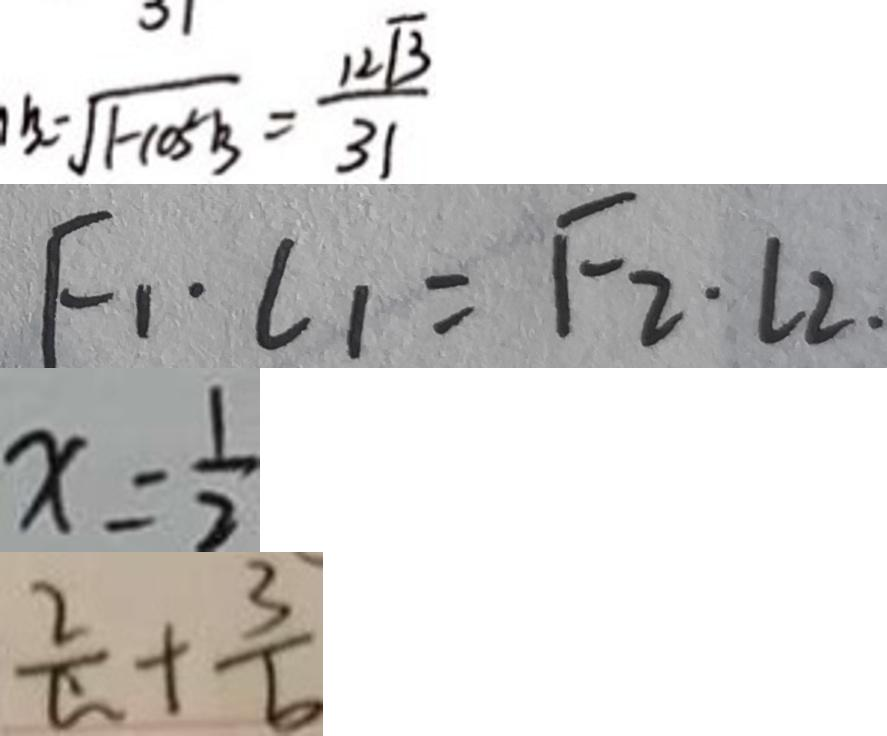Convert formula to latex. <formula><loc_0><loc_0><loc_500><loc_500>B = \sqrt { 1 - \cos ^ { 2 } B } = \frac { 1 2 \sqrt { 3 } } { 3 1 } 
 F _ { 1 } \cdot l _ { 1 } = F _ { 2 } \cdot L 2 . 
 x = \frac { 1 } { 2 } 
 \frac { 2 } { a } + \frac { 3 } { b }</formula> 